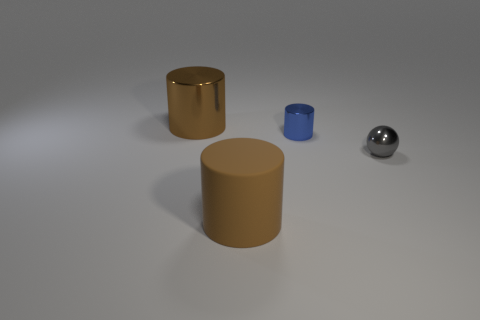What material is the other object that is the same color as the rubber object?
Provide a succinct answer. Metal. There is another big object that is the same shape as the brown shiny object; what is it made of?
Your answer should be compact. Rubber. Is the color of the large rubber object the same as the big metal object?
Make the answer very short. Yes. How many other objects are the same shape as the matte object?
Offer a very short reply. 2. Do the cylinder that is right of the matte object and the small sphere have the same size?
Your answer should be very brief. Yes. Is the number of cylinders that are left of the big brown rubber thing greater than the number of big cyan metal things?
Your response must be concise. Yes. There is a big cylinder that is behind the large brown rubber cylinder; how many things are on the right side of it?
Offer a terse response. 3. Are there fewer tiny balls behind the tiny blue cylinder than large red matte balls?
Offer a very short reply. No. There is a big brown cylinder behind the large brown cylinder that is in front of the brown metal thing; is there a small blue metallic object left of it?
Your answer should be compact. No. Is the blue object made of the same material as the big cylinder right of the large metallic object?
Give a very brief answer. No. 